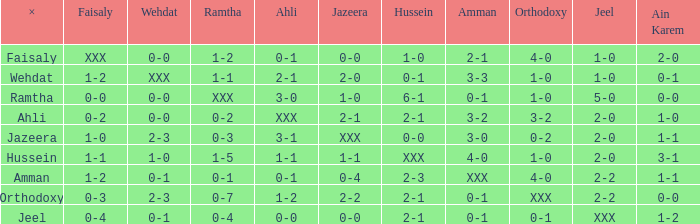What is x when faisaly is 0-0? Ramtha. 